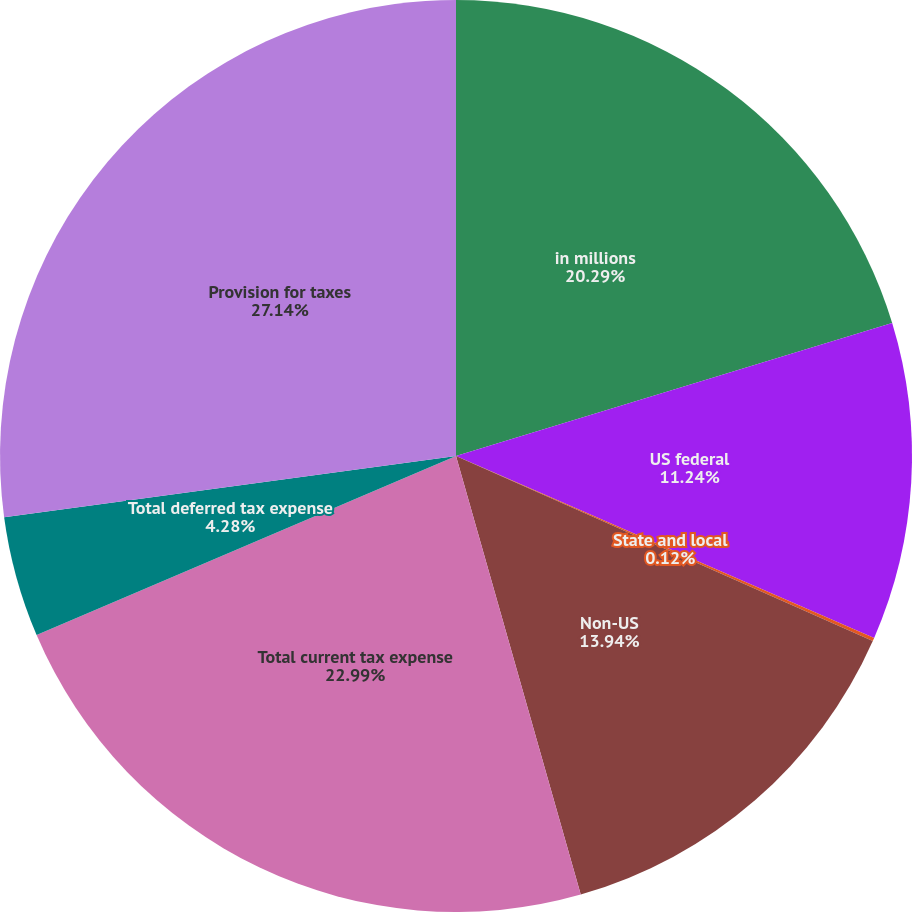Convert chart. <chart><loc_0><loc_0><loc_500><loc_500><pie_chart><fcel>in millions<fcel>US federal<fcel>State and local<fcel>Non-US<fcel>Total current tax expense<fcel>Total deferred tax expense<fcel>Provision for taxes<nl><fcel>20.29%<fcel>11.24%<fcel>0.12%<fcel>13.94%<fcel>22.99%<fcel>4.28%<fcel>27.14%<nl></chart> 